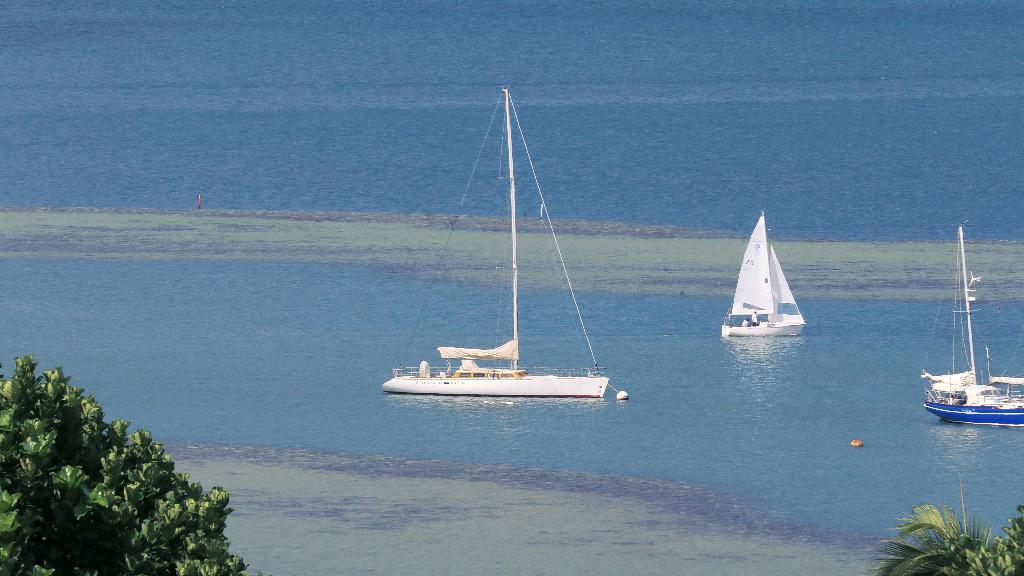What type of vegetation is at the bottom of the picture? There are trees at the bottom of the picture. What natural element is visible in the image? Water is visible in the image. What is the water body in the picture? There is a water body in the picture. What type of transportation can be seen in the water? Boats are present in the water. Where are the boats located in the picture? The boats are in the center of the picture. What type of sponge is floating on the water in the image? There is no sponge present in the image; it features trees, water, a water body, and boats. Can you see any ghosts in the image? There are no ghosts present in the image. 